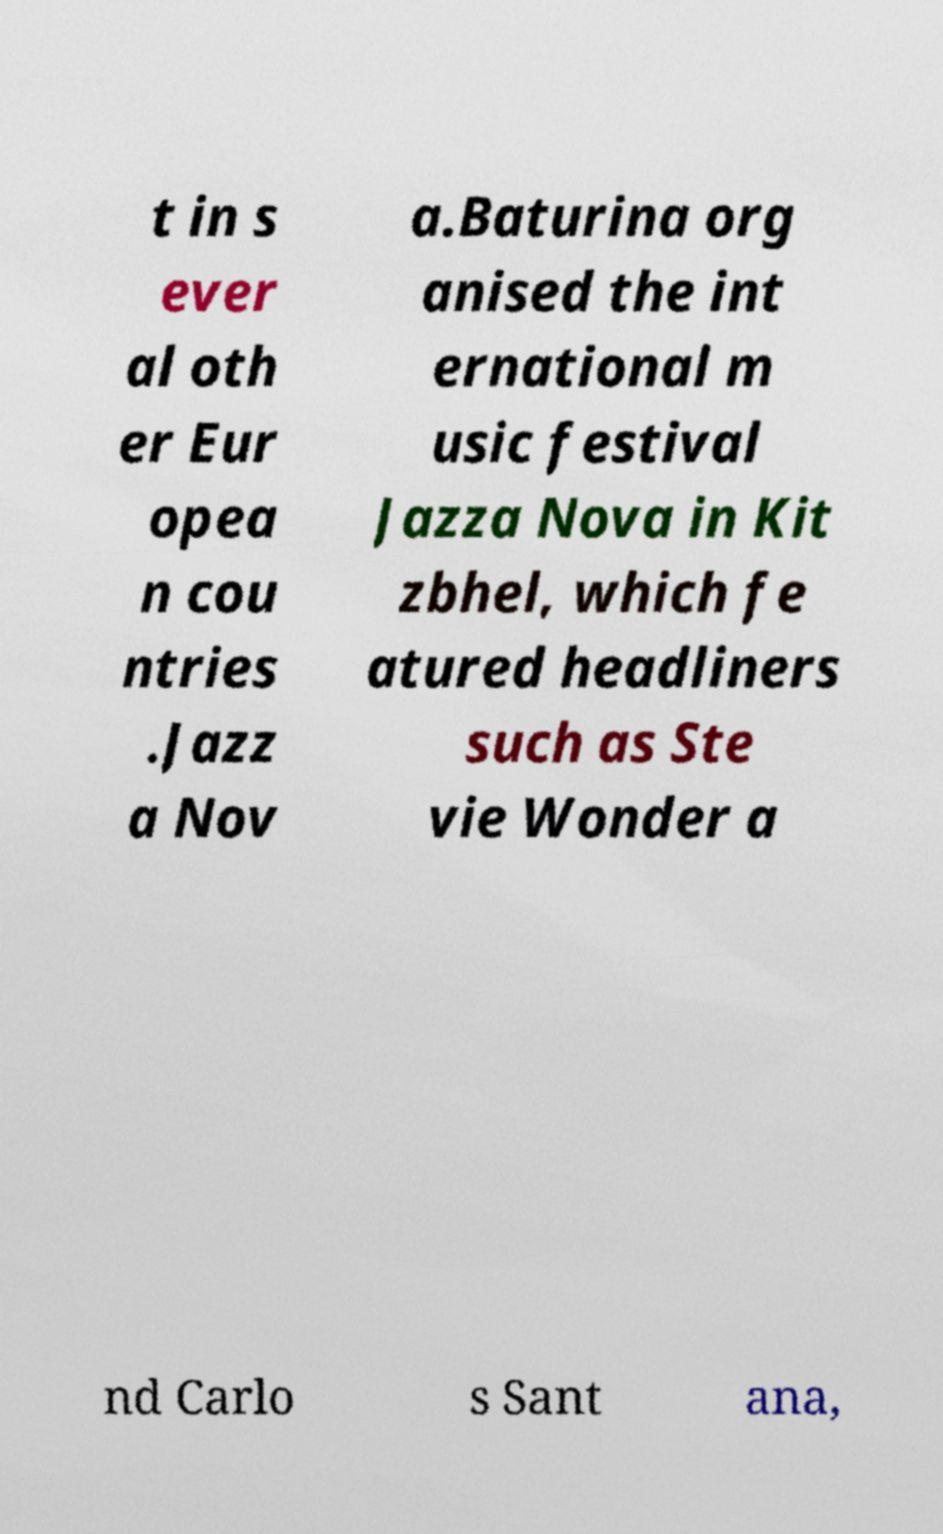For documentation purposes, I need the text within this image transcribed. Could you provide that? t in s ever al oth er Eur opea n cou ntries .Jazz a Nov a.Baturina org anised the int ernational m usic festival Jazza Nova in Kit zbhel, which fe atured headliners such as Ste vie Wonder a nd Carlo s Sant ana, 